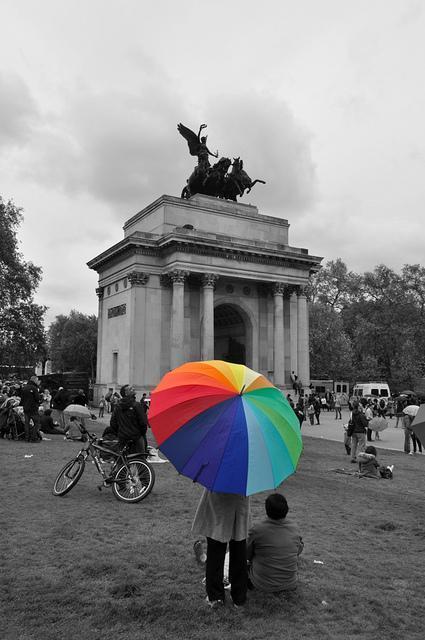How many umbrellas are in the picture?
Give a very brief answer. 1. How many people are visible?
Give a very brief answer. 3. 